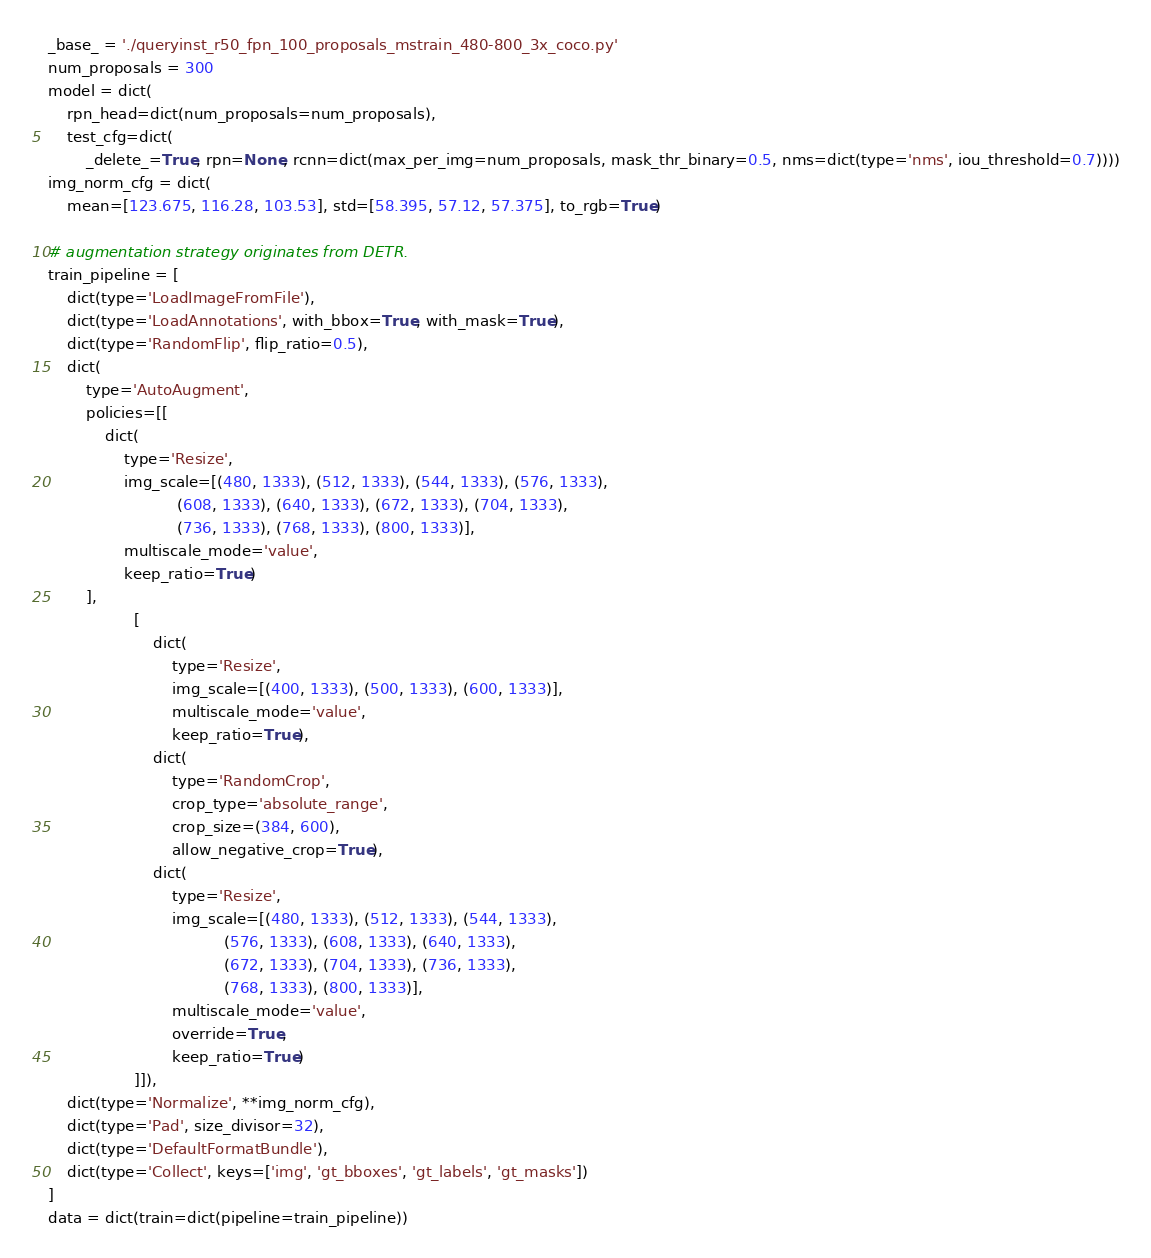Convert code to text. <code><loc_0><loc_0><loc_500><loc_500><_Python_>_base_ = './queryinst_r50_fpn_100_proposals_mstrain_480-800_3x_coco.py'
num_proposals = 300
model = dict(
    rpn_head=dict(num_proposals=num_proposals),
    test_cfg=dict(
        _delete_=True, rpn=None, rcnn=dict(max_per_img=num_proposals, mask_thr_binary=0.5, nms=dict(type='nms', iou_threshold=0.7))))
img_norm_cfg = dict(
    mean=[123.675, 116.28, 103.53], std=[58.395, 57.12, 57.375], to_rgb=True)

# augmentation strategy originates from DETR.
train_pipeline = [
    dict(type='LoadImageFromFile'),
    dict(type='LoadAnnotations', with_bbox=True, with_mask=True),
    dict(type='RandomFlip', flip_ratio=0.5),
    dict(
        type='AutoAugment',
        policies=[[
            dict(
                type='Resize',
                img_scale=[(480, 1333), (512, 1333), (544, 1333), (576, 1333),
                           (608, 1333), (640, 1333), (672, 1333), (704, 1333),
                           (736, 1333), (768, 1333), (800, 1333)],
                multiscale_mode='value',
                keep_ratio=True)
        ],
                  [
                      dict(
                          type='Resize',
                          img_scale=[(400, 1333), (500, 1333), (600, 1333)],
                          multiscale_mode='value',
                          keep_ratio=True),
                      dict(
                          type='RandomCrop',
                          crop_type='absolute_range',
                          crop_size=(384, 600),
                          allow_negative_crop=True),
                      dict(
                          type='Resize',
                          img_scale=[(480, 1333), (512, 1333), (544, 1333),
                                     (576, 1333), (608, 1333), (640, 1333),
                                     (672, 1333), (704, 1333), (736, 1333),
                                     (768, 1333), (800, 1333)],
                          multiscale_mode='value',
                          override=True,
                          keep_ratio=True)
                  ]]),
    dict(type='Normalize', **img_norm_cfg),
    dict(type='Pad', size_divisor=32),
    dict(type='DefaultFormatBundle'),
    dict(type='Collect', keys=['img', 'gt_bboxes', 'gt_labels', 'gt_masks'])
]
data = dict(train=dict(pipeline=train_pipeline))
</code> 